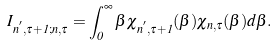Convert formula to latex. <formula><loc_0><loc_0><loc_500><loc_500>I _ { n ^ { ^ { \prime } } , \tau + 1 ; n , \tau } = \int _ { 0 } ^ { \infty } \beta \chi _ { n ^ { ^ { \prime } } , \tau + 1 } ( \beta ) \chi _ { n , \tau } ( \beta ) d \beta .</formula> 